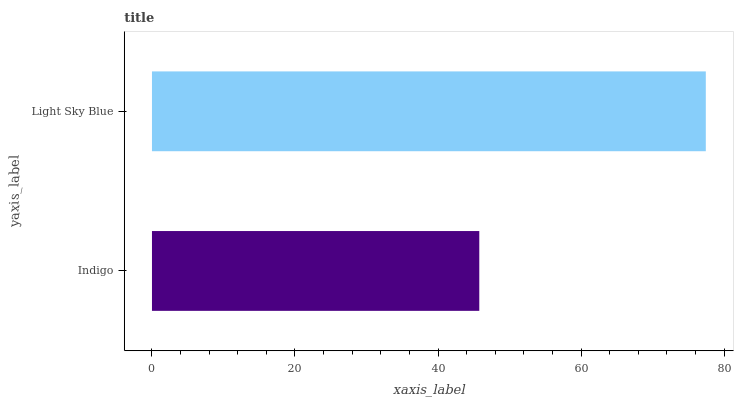Is Indigo the minimum?
Answer yes or no. Yes. Is Light Sky Blue the maximum?
Answer yes or no. Yes. Is Light Sky Blue the minimum?
Answer yes or no. No. Is Light Sky Blue greater than Indigo?
Answer yes or no. Yes. Is Indigo less than Light Sky Blue?
Answer yes or no. Yes. Is Indigo greater than Light Sky Blue?
Answer yes or no. No. Is Light Sky Blue less than Indigo?
Answer yes or no. No. Is Light Sky Blue the high median?
Answer yes or no. Yes. Is Indigo the low median?
Answer yes or no. Yes. Is Indigo the high median?
Answer yes or no. No. Is Light Sky Blue the low median?
Answer yes or no. No. 